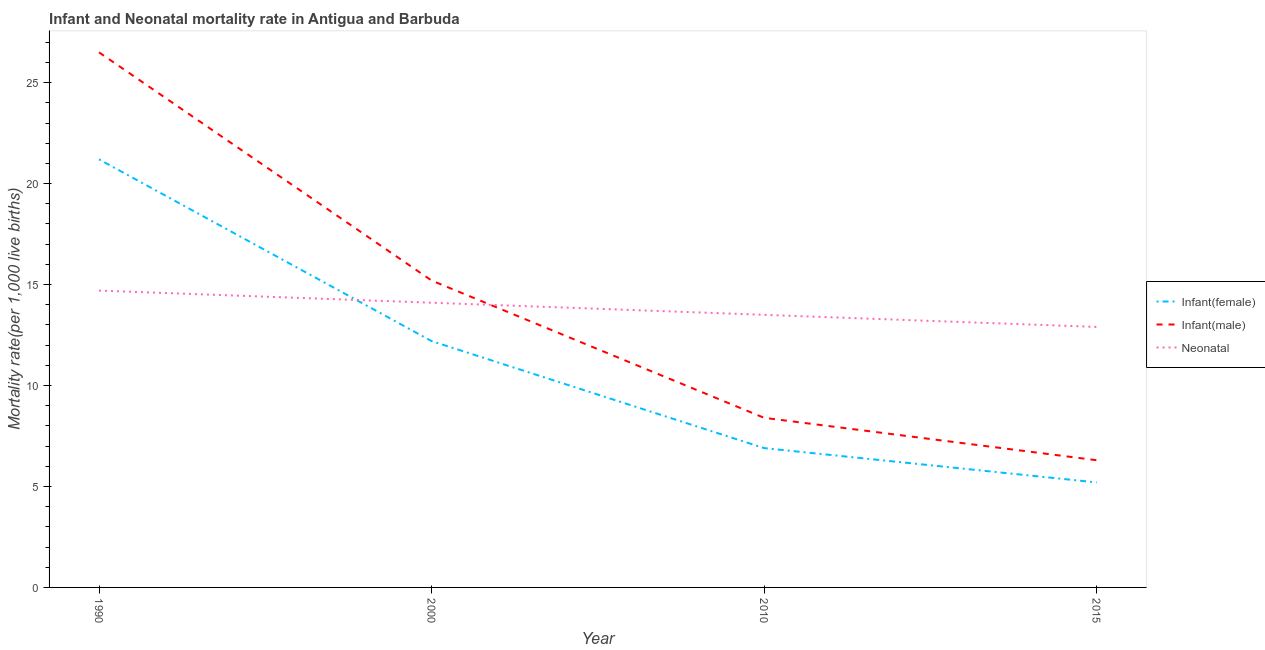Does the line corresponding to infant mortality rate(female) intersect with the line corresponding to infant mortality rate(male)?
Keep it short and to the point. No. Is the number of lines equal to the number of legend labels?
Offer a very short reply. Yes. What is the infant mortality rate(male) in 2000?
Your answer should be compact. 15.2. Across all years, what is the maximum neonatal mortality rate?
Your answer should be very brief. 14.7. In which year was the infant mortality rate(male) maximum?
Your answer should be very brief. 1990. In which year was the infant mortality rate(male) minimum?
Keep it short and to the point. 2015. What is the total neonatal mortality rate in the graph?
Your response must be concise. 55.2. What is the difference between the infant mortality rate(male) in 1990 and that in 2010?
Provide a succinct answer. 18.1. What is the difference between the neonatal mortality rate in 2010 and the infant mortality rate(female) in 1990?
Ensure brevity in your answer.  -7.7. What is the average infant mortality rate(female) per year?
Offer a very short reply. 11.38. In the year 2000, what is the difference between the neonatal mortality rate and infant mortality rate(female)?
Your answer should be very brief. 1.9. In how many years, is the infant mortality rate(male) greater than 7?
Offer a very short reply. 3. What is the ratio of the infant mortality rate(male) in 2010 to that in 2015?
Your answer should be compact. 1.33. Is the infant mortality rate(male) in 2000 less than that in 2010?
Provide a succinct answer. No. Is the difference between the infant mortality rate(female) in 2000 and 2010 greater than the difference between the neonatal mortality rate in 2000 and 2010?
Keep it short and to the point. Yes. What is the difference between the highest and the second highest neonatal mortality rate?
Your answer should be very brief. 0.6. What is the difference between the highest and the lowest infant mortality rate(male)?
Provide a short and direct response. 20.2. Is it the case that in every year, the sum of the infant mortality rate(female) and infant mortality rate(male) is greater than the neonatal mortality rate?
Offer a terse response. No. Does the infant mortality rate(female) monotonically increase over the years?
Ensure brevity in your answer.  No. Is the neonatal mortality rate strictly less than the infant mortality rate(male) over the years?
Ensure brevity in your answer.  No. How many lines are there?
Your answer should be very brief. 3. How many years are there in the graph?
Ensure brevity in your answer.  4. Are the values on the major ticks of Y-axis written in scientific E-notation?
Offer a terse response. No. Does the graph contain any zero values?
Offer a very short reply. No. Where does the legend appear in the graph?
Make the answer very short. Center right. How many legend labels are there?
Keep it short and to the point. 3. What is the title of the graph?
Ensure brevity in your answer.  Infant and Neonatal mortality rate in Antigua and Barbuda. Does "Grants" appear as one of the legend labels in the graph?
Offer a terse response. No. What is the label or title of the Y-axis?
Make the answer very short. Mortality rate(per 1,0 live births). What is the Mortality rate(per 1,000 live births) of Infant(female) in 1990?
Your response must be concise. 21.2. What is the Mortality rate(per 1,000 live births) in Neonatal  in 1990?
Make the answer very short. 14.7. What is the Mortality rate(per 1,000 live births) of Infant(female) in 2000?
Keep it short and to the point. 12.2. What is the Mortality rate(per 1,000 live births) of Infant(male) in 2000?
Give a very brief answer. 15.2. What is the Mortality rate(per 1,000 live births) of Infant(male) in 2010?
Make the answer very short. 8.4. What is the Mortality rate(per 1,000 live births) of Neonatal  in 2010?
Offer a terse response. 13.5. What is the Mortality rate(per 1,000 live births) in Infant(female) in 2015?
Your answer should be very brief. 5.2. What is the Mortality rate(per 1,000 live births) of Infant(male) in 2015?
Your answer should be very brief. 6.3. What is the Mortality rate(per 1,000 live births) in Neonatal  in 2015?
Give a very brief answer. 12.9. Across all years, what is the maximum Mortality rate(per 1,000 live births) of Infant(female)?
Your response must be concise. 21.2. Across all years, what is the maximum Mortality rate(per 1,000 live births) of Neonatal ?
Keep it short and to the point. 14.7. Across all years, what is the minimum Mortality rate(per 1,000 live births) in Neonatal ?
Offer a terse response. 12.9. What is the total Mortality rate(per 1,000 live births) of Infant(female) in the graph?
Make the answer very short. 45.5. What is the total Mortality rate(per 1,000 live births) of Infant(male) in the graph?
Your answer should be very brief. 56.4. What is the total Mortality rate(per 1,000 live births) in Neonatal  in the graph?
Make the answer very short. 55.2. What is the difference between the Mortality rate(per 1,000 live births) in Infant(female) in 1990 and that in 2000?
Ensure brevity in your answer.  9. What is the difference between the Mortality rate(per 1,000 live births) in Neonatal  in 1990 and that in 2000?
Give a very brief answer. 0.6. What is the difference between the Mortality rate(per 1,000 live births) of Infant(female) in 1990 and that in 2010?
Make the answer very short. 14.3. What is the difference between the Mortality rate(per 1,000 live births) of Neonatal  in 1990 and that in 2010?
Give a very brief answer. 1.2. What is the difference between the Mortality rate(per 1,000 live births) in Infant(female) in 1990 and that in 2015?
Ensure brevity in your answer.  16. What is the difference between the Mortality rate(per 1,000 live births) in Infant(male) in 1990 and that in 2015?
Ensure brevity in your answer.  20.2. What is the difference between the Mortality rate(per 1,000 live births) of Infant(male) in 2010 and that in 2015?
Provide a short and direct response. 2.1. What is the difference between the Mortality rate(per 1,000 live births) in Infant(female) in 1990 and the Mortality rate(per 1,000 live births) in Infant(male) in 2000?
Your answer should be very brief. 6. What is the difference between the Mortality rate(per 1,000 live births) in Infant(female) in 1990 and the Mortality rate(per 1,000 live births) in Neonatal  in 2000?
Your answer should be compact. 7.1. What is the difference between the Mortality rate(per 1,000 live births) in Infant(male) in 1990 and the Mortality rate(per 1,000 live births) in Neonatal  in 2000?
Your answer should be very brief. 12.4. What is the difference between the Mortality rate(per 1,000 live births) of Infant(female) in 1990 and the Mortality rate(per 1,000 live births) of Infant(male) in 2010?
Offer a very short reply. 12.8. What is the difference between the Mortality rate(per 1,000 live births) of Infant(female) in 1990 and the Mortality rate(per 1,000 live births) of Neonatal  in 2010?
Offer a terse response. 7.7. What is the difference between the Mortality rate(per 1,000 live births) in Infant(male) in 1990 and the Mortality rate(per 1,000 live births) in Neonatal  in 2010?
Offer a very short reply. 13. What is the difference between the Mortality rate(per 1,000 live births) in Infant(male) in 2000 and the Mortality rate(per 1,000 live births) in Neonatal  in 2010?
Make the answer very short. 1.7. What is the difference between the Mortality rate(per 1,000 live births) of Infant(female) in 2000 and the Mortality rate(per 1,000 live births) of Neonatal  in 2015?
Make the answer very short. -0.7. What is the difference between the Mortality rate(per 1,000 live births) in Infant(female) in 2010 and the Mortality rate(per 1,000 live births) in Neonatal  in 2015?
Your answer should be compact. -6. What is the difference between the Mortality rate(per 1,000 live births) of Infant(male) in 2010 and the Mortality rate(per 1,000 live births) of Neonatal  in 2015?
Your response must be concise. -4.5. What is the average Mortality rate(per 1,000 live births) in Infant(female) per year?
Keep it short and to the point. 11.38. What is the average Mortality rate(per 1,000 live births) in Neonatal  per year?
Give a very brief answer. 13.8. In the year 1990, what is the difference between the Mortality rate(per 1,000 live births) in Infant(female) and Mortality rate(per 1,000 live births) in Neonatal ?
Your response must be concise. 6.5. In the year 2000, what is the difference between the Mortality rate(per 1,000 live births) in Infant(female) and Mortality rate(per 1,000 live births) in Infant(male)?
Give a very brief answer. -3. In the year 2000, what is the difference between the Mortality rate(per 1,000 live births) of Infant(female) and Mortality rate(per 1,000 live births) of Neonatal ?
Give a very brief answer. -1.9. In the year 2010, what is the difference between the Mortality rate(per 1,000 live births) in Infant(female) and Mortality rate(per 1,000 live births) in Infant(male)?
Offer a terse response. -1.5. In the year 2010, what is the difference between the Mortality rate(per 1,000 live births) in Infant(female) and Mortality rate(per 1,000 live births) in Neonatal ?
Your answer should be very brief. -6.6. In the year 2015, what is the difference between the Mortality rate(per 1,000 live births) of Infant(female) and Mortality rate(per 1,000 live births) of Infant(male)?
Give a very brief answer. -1.1. In the year 2015, what is the difference between the Mortality rate(per 1,000 live births) of Infant(female) and Mortality rate(per 1,000 live births) of Neonatal ?
Your answer should be compact. -7.7. In the year 2015, what is the difference between the Mortality rate(per 1,000 live births) of Infant(male) and Mortality rate(per 1,000 live births) of Neonatal ?
Your answer should be very brief. -6.6. What is the ratio of the Mortality rate(per 1,000 live births) of Infant(female) in 1990 to that in 2000?
Provide a short and direct response. 1.74. What is the ratio of the Mortality rate(per 1,000 live births) of Infant(male) in 1990 to that in 2000?
Ensure brevity in your answer.  1.74. What is the ratio of the Mortality rate(per 1,000 live births) in Neonatal  in 1990 to that in 2000?
Your response must be concise. 1.04. What is the ratio of the Mortality rate(per 1,000 live births) in Infant(female) in 1990 to that in 2010?
Your response must be concise. 3.07. What is the ratio of the Mortality rate(per 1,000 live births) in Infant(male) in 1990 to that in 2010?
Your response must be concise. 3.15. What is the ratio of the Mortality rate(per 1,000 live births) in Neonatal  in 1990 to that in 2010?
Offer a terse response. 1.09. What is the ratio of the Mortality rate(per 1,000 live births) in Infant(female) in 1990 to that in 2015?
Your response must be concise. 4.08. What is the ratio of the Mortality rate(per 1,000 live births) of Infant(male) in 1990 to that in 2015?
Make the answer very short. 4.21. What is the ratio of the Mortality rate(per 1,000 live births) in Neonatal  in 1990 to that in 2015?
Your answer should be very brief. 1.14. What is the ratio of the Mortality rate(per 1,000 live births) in Infant(female) in 2000 to that in 2010?
Make the answer very short. 1.77. What is the ratio of the Mortality rate(per 1,000 live births) in Infant(male) in 2000 to that in 2010?
Make the answer very short. 1.81. What is the ratio of the Mortality rate(per 1,000 live births) of Neonatal  in 2000 to that in 2010?
Offer a terse response. 1.04. What is the ratio of the Mortality rate(per 1,000 live births) of Infant(female) in 2000 to that in 2015?
Your answer should be compact. 2.35. What is the ratio of the Mortality rate(per 1,000 live births) of Infant(male) in 2000 to that in 2015?
Your answer should be compact. 2.41. What is the ratio of the Mortality rate(per 1,000 live births) in Neonatal  in 2000 to that in 2015?
Your response must be concise. 1.09. What is the ratio of the Mortality rate(per 1,000 live births) in Infant(female) in 2010 to that in 2015?
Your response must be concise. 1.33. What is the ratio of the Mortality rate(per 1,000 live births) of Infant(male) in 2010 to that in 2015?
Give a very brief answer. 1.33. What is the ratio of the Mortality rate(per 1,000 live births) in Neonatal  in 2010 to that in 2015?
Give a very brief answer. 1.05. What is the difference between the highest and the second highest Mortality rate(per 1,000 live births) of Infant(male)?
Your response must be concise. 11.3. What is the difference between the highest and the lowest Mortality rate(per 1,000 live births) in Infant(female)?
Make the answer very short. 16. What is the difference between the highest and the lowest Mortality rate(per 1,000 live births) in Infant(male)?
Make the answer very short. 20.2. What is the difference between the highest and the lowest Mortality rate(per 1,000 live births) in Neonatal ?
Provide a succinct answer. 1.8. 